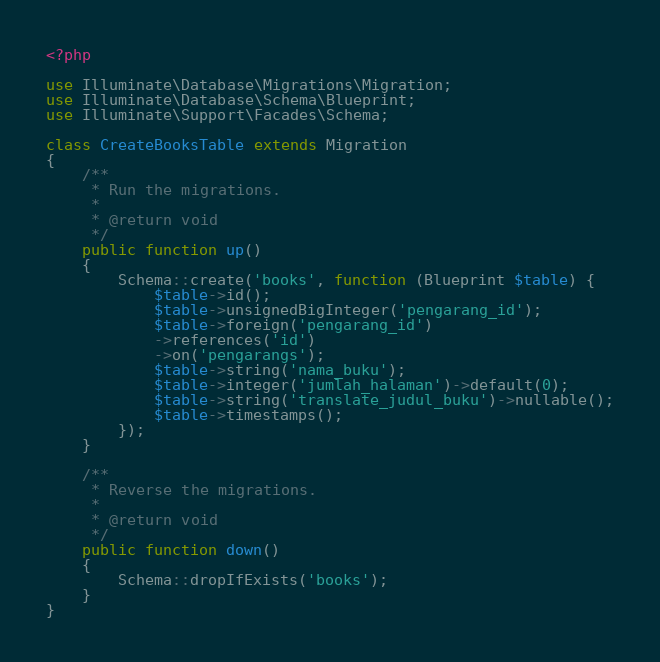Convert code to text. <code><loc_0><loc_0><loc_500><loc_500><_PHP_><?php

use Illuminate\Database\Migrations\Migration;
use Illuminate\Database\Schema\Blueprint;
use Illuminate\Support\Facades\Schema;

class CreateBooksTable extends Migration
{
    /**
     * Run the migrations.
     *
     * @return void
     */
    public function up()
    {
        Schema::create('books', function (Blueprint $table) {
            $table->id();
            $table->unsignedBigInteger('pengarang_id');
            $table->foreign('pengarang_id')
            ->references('id')
            ->on('pengarangs');
            $table->string('nama_buku');
            $table->integer('jumlah_halaman')->default(0);
            $table->string('translate_judul_buku')->nullable();
            $table->timestamps();
        });
    }

    /**
     * Reverse the migrations.
     *
     * @return void
     */
    public function down()
    {
        Schema::dropIfExists('books');
    }
}
</code> 